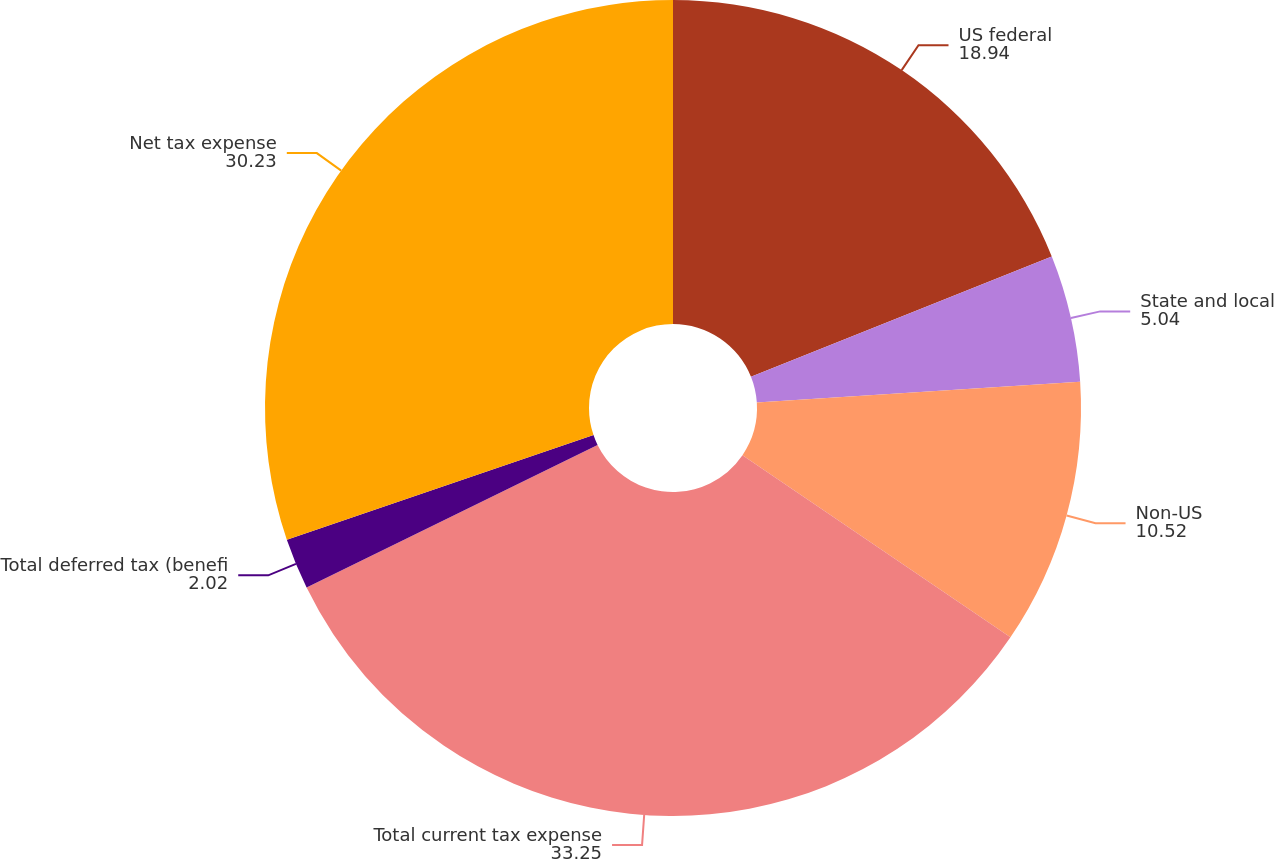Convert chart. <chart><loc_0><loc_0><loc_500><loc_500><pie_chart><fcel>US federal<fcel>State and local<fcel>Non-US<fcel>Total current tax expense<fcel>Total deferred tax (benefi<fcel>Net tax expense<nl><fcel>18.94%<fcel>5.04%<fcel>10.52%<fcel>33.25%<fcel>2.02%<fcel>30.23%<nl></chart> 